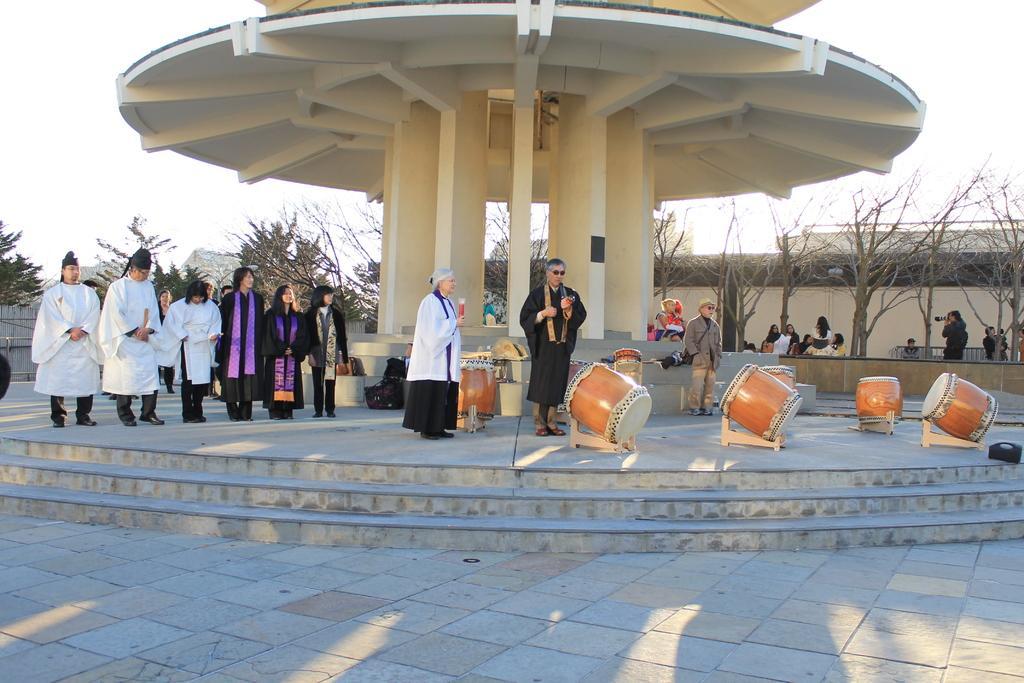How would you summarize this image in a sentence or two? In this picture there are few people standing in a line. there are other two people standing in the center. There are drugs placed on drum stands on the floor. In the background there is a building, tree and sky. There is a man to the right corner holding a camera in his hand. 